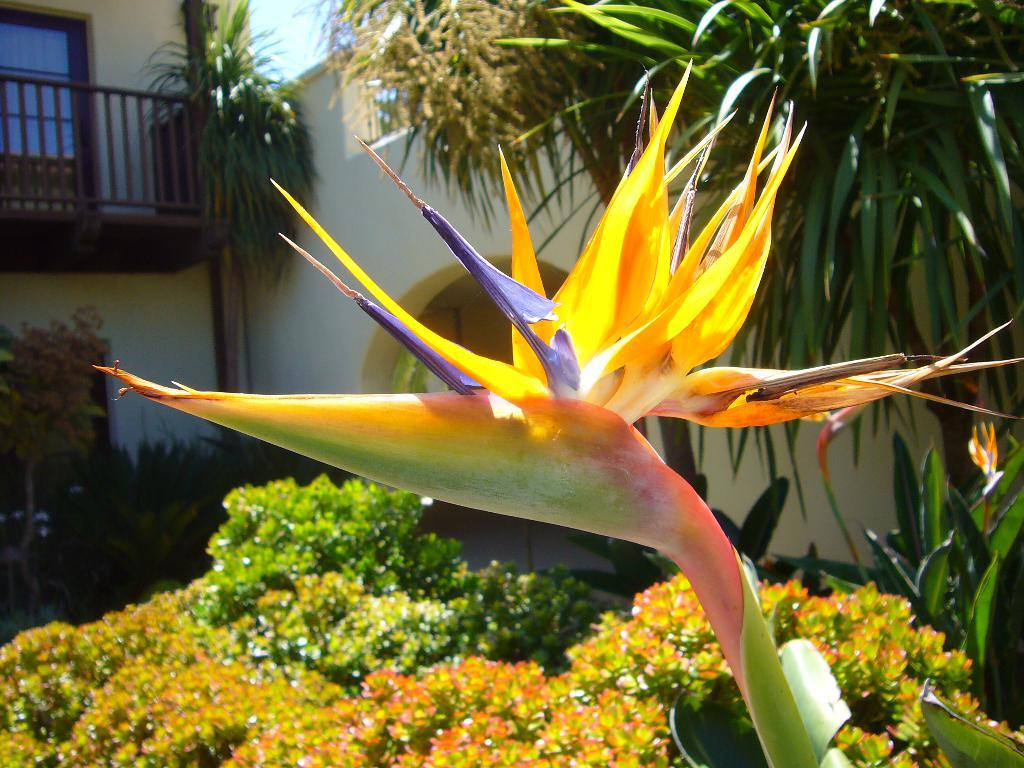What is the main subject of the image? There is a flower in the image. What can be seen in the background of the image? There are plants in the background of the image. What type of structure is present in the image? There is a building with railing and arch in the image. What type of dock can be seen near the flower in the image? There is no dock present in the image. What kind of thing is the writer using to create the image? The facts provided do not mention a writer or any tools used to create the image. 